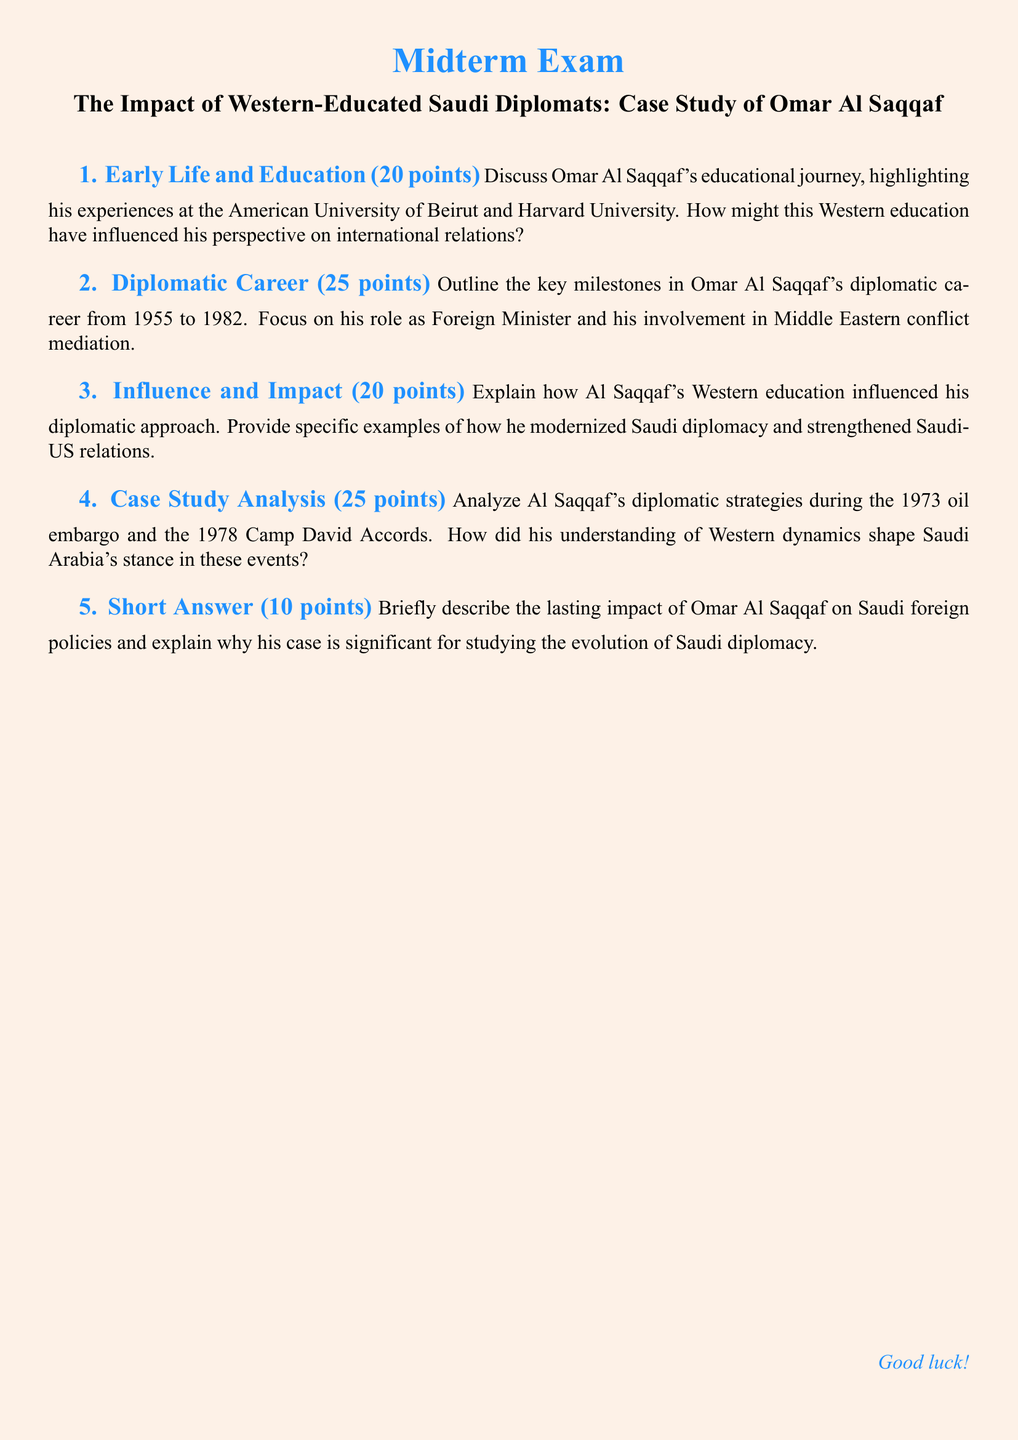What institution did Omar Al Saqqaf attend for higher education? The document mentions that Omar Al Saqqaf attended the American University of Beirut and Harvard University for his education.
Answer: American University of Beirut, Harvard University What is the total number of points assigned to the Early Life and Education section? The document specifies that the Early Life and Education section is worth 20 points.
Answer: 20 points During which years did Omar Al Saqqaf have a significant diplomatic career? The document outlines key milestones in Omar Al Saqqaf's career from 1955 to 1982.
Answer: 1955 to 1982 What major event is highlighted in relation to Al Saqqaf's diplomatic strategies during the 1970s? The document references the 1973 oil embargo and the 1978 Camp David Accords as significant events in which Al Saqqaf's strategies were important.
Answer: 1973 oil embargo, 1978 Camp David Accords How many points is the Influence and Impact section worth? The document states that the Influence and Impact section is worth 20 points.
Answer: 20 points What is the point value assigned to the Short Answer question in the exam? The document indicates that the Short Answer question is worth 10 points.
Answer: 10 points What key role did Omar Al Saqqaf play as mentioned in the document? The document highlights his role as Foreign Minister.
Answer: Foreign Minister What is the main purpose of the document? The document serves as a midterm exam focused on the impact of Western-educated Saudi diplomats, specifically Omar Al Saqqaf.
Answer: Midterm exam 